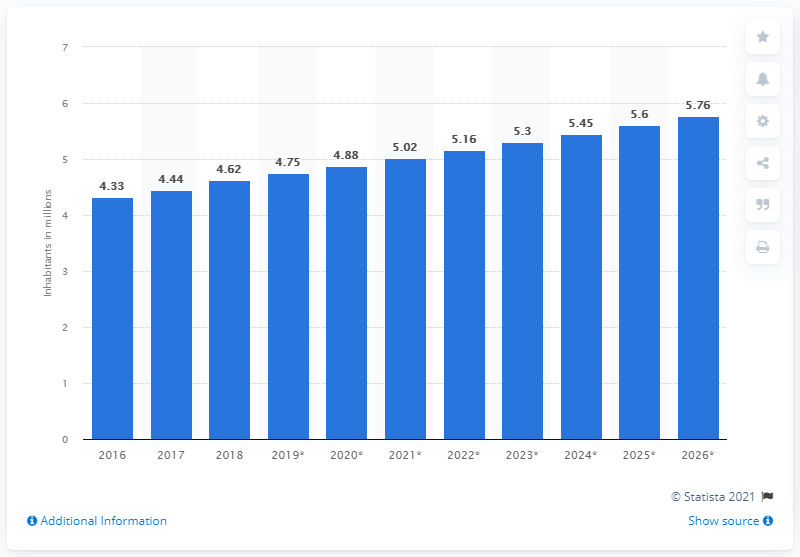Does the chart indicate any possible population decline or stagnation in the future? The chart does not indicate any decline or stagnation; instead, it shows a continuous and steady population growth for Kuwait from 2016 to the projected population for 2026. 